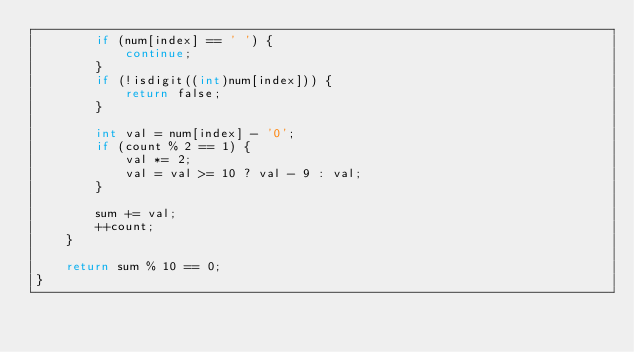Convert code to text. <code><loc_0><loc_0><loc_500><loc_500><_C_>        if (num[index] == ' ') {
            continue;
        }
        if (!isdigit((int)num[index])) {
            return false;
        }

        int val = num[index] - '0';
        if (count % 2 == 1) {
            val *= 2;
            val = val >= 10 ? val - 9 : val;
        }

        sum += val;
        ++count;
    }

    return sum % 10 == 0;
}
</code> 